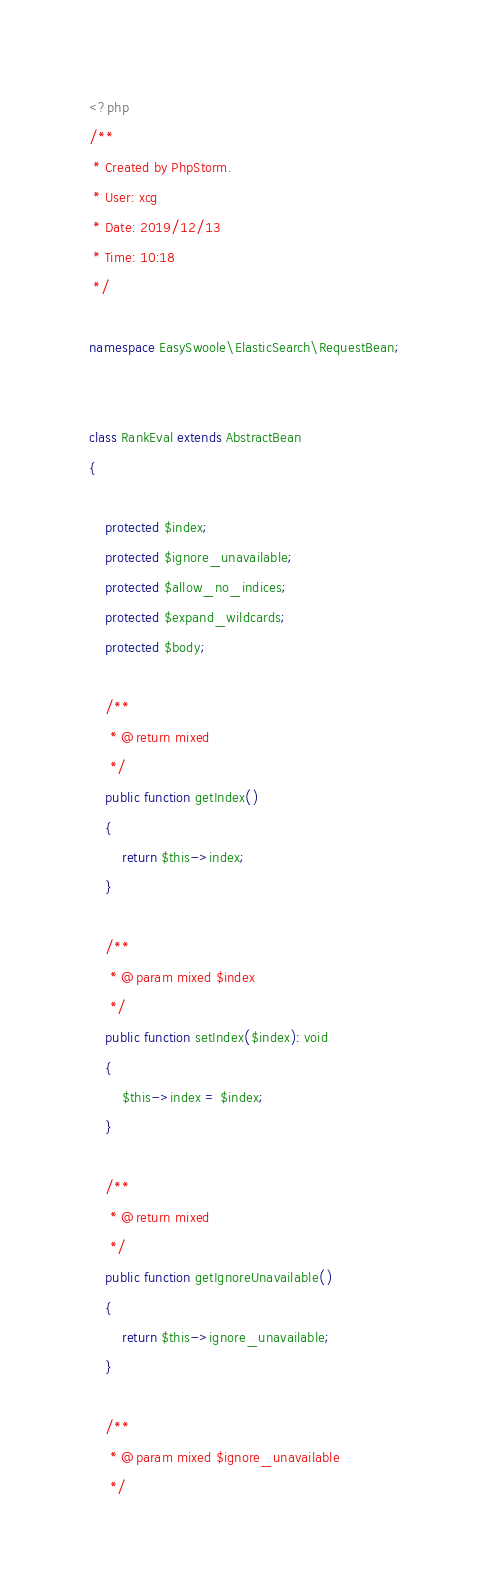Convert code to text. <code><loc_0><loc_0><loc_500><loc_500><_PHP_><?php
/**
 * Created by PhpStorm.
 * User: xcg
 * Date: 2019/12/13
 * Time: 10:18
 */

namespace EasySwoole\ElasticSearch\RequestBean;


class RankEval extends AbstractBean
{

    protected $index;
    protected $ignore_unavailable;
    protected $allow_no_indices;
    protected $expand_wildcards;
    protected $body;

    /**
     * @return mixed
     */
    public function getIndex()
    {
        return $this->index;
    }

    /**
     * @param mixed $index
     */
    public function setIndex($index): void
    {
        $this->index = $index;
    }

    /**
     * @return mixed
     */
    public function getIgnoreUnavailable()
    {
        return $this->ignore_unavailable;
    }

    /**
     * @param mixed $ignore_unavailable
     */</code> 